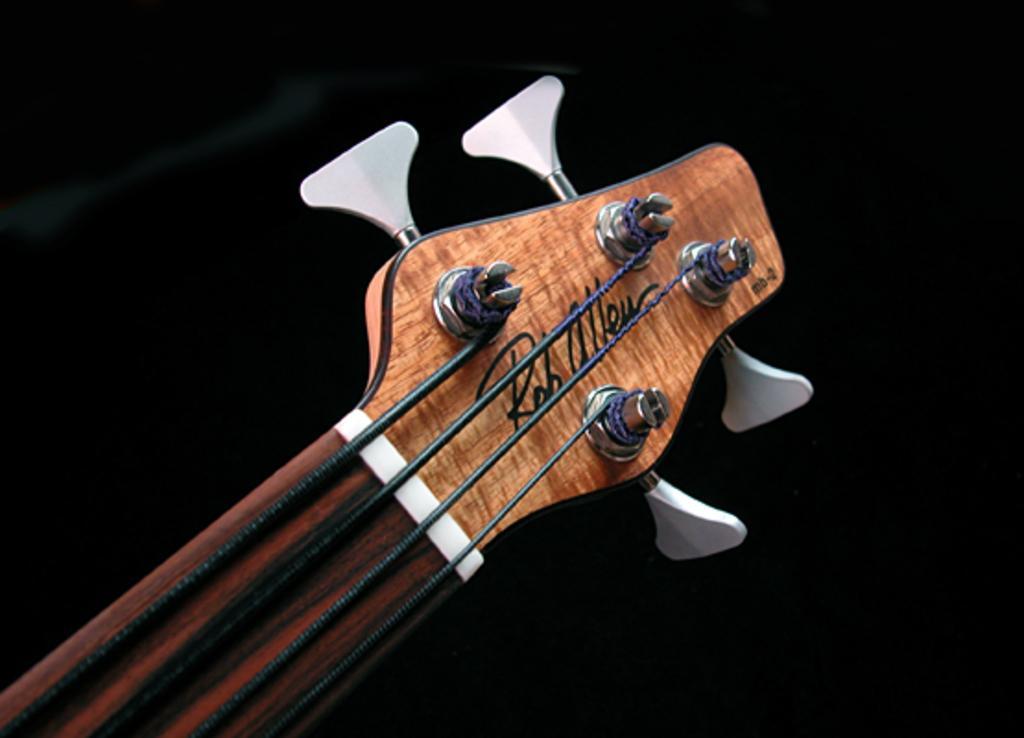Describe this image in one or two sentences. In this picture a guitar top most part is displayed and the label ROHALLEU is written on it. 